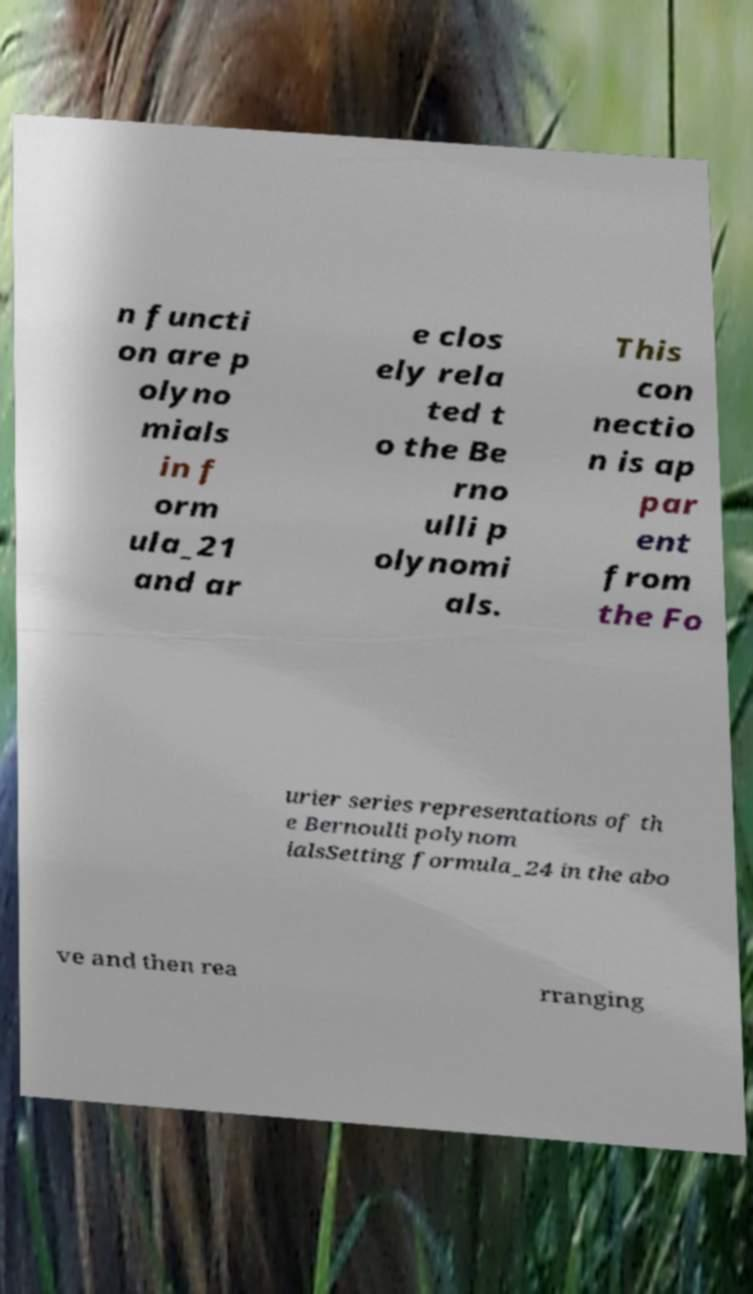I need the written content from this picture converted into text. Can you do that? n functi on are p olyno mials in f orm ula_21 and ar e clos ely rela ted t o the Be rno ulli p olynomi als. This con nectio n is ap par ent from the Fo urier series representations of th e Bernoulli polynom ialsSetting formula_24 in the abo ve and then rea rranging 